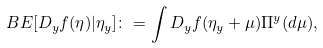<formula> <loc_0><loc_0><loc_500><loc_500>\ B E [ D _ { y } f ( \eta ) | \eta _ { y } ] \colon = \int D _ { y } f ( \eta _ { y } + \mu ) \Pi ^ { y } ( d \mu ) ,</formula> 